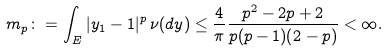Convert formula to latex. <formula><loc_0><loc_0><loc_500><loc_500>m _ { p } \colon = \int _ { E } | y _ { 1 } - 1 | ^ { p } \, \nu ( d y ) \leq \frac { 4 } { \pi } \frac { p ^ { 2 } - 2 p + 2 } { p ( p - 1 ) ( 2 - p ) } < \infty .</formula> 